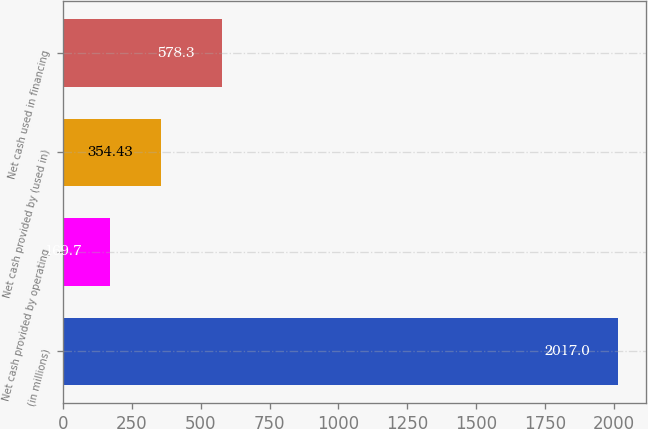Convert chart to OTSL. <chart><loc_0><loc_0><loc_500><loc_500><bar_chart><fcel>(in millions)<fcel>Net cash provided by operating<fcel>Net cash provided by (used in)<fcel>Net cash used in financing<nl><fcel>2017<fcel>169.7<fcel>354.43<fcel>578.3<nl></chart> 